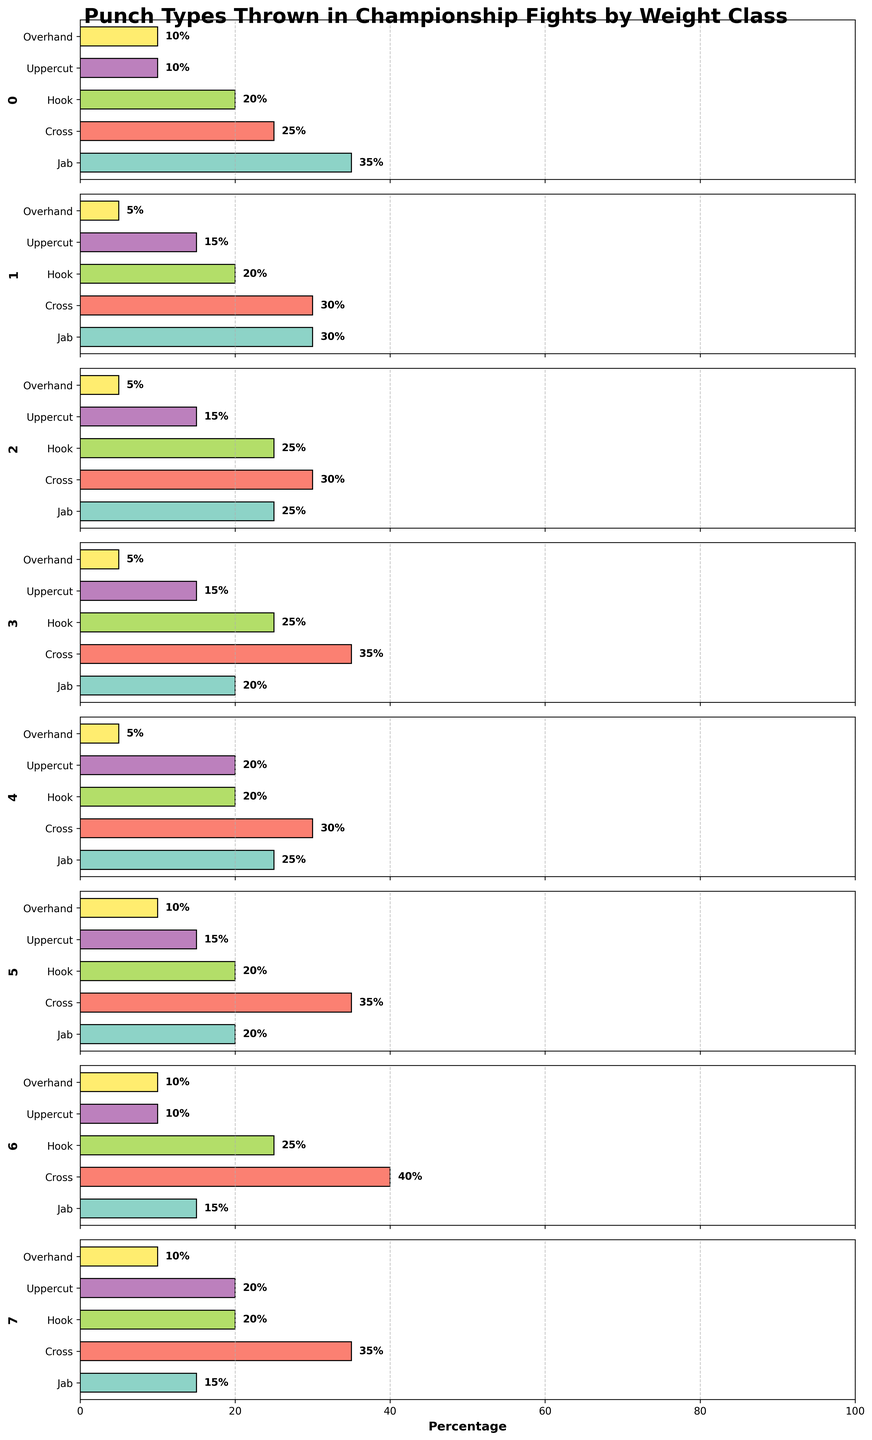What is the title of the figure? The title is usually found at the top of the figure, describing its content.
Answer: Punch Types Thrown in Championship Fights by Weight Class Which punch type has the highest percentage for Flyweight? To find this, look at the Flyweight subplot and identify the punch with the longest bar.
Answer: Jab What is the total percentage of punches thrown for Bantamweight? Add up the percentages of all punch types in the Bantamweight subplot: 30 + 30 + 20 + 15 + 5.
Answer: 100% Which weight class throws the highest percentage of Cross punches? Examine the bars for Cross punches in each subplot and find the weight class with the longest bar.
Answer: Light Heavyweight How many data points are represented in the figure? Each subplot represents one weight class, and each weight class has five punch types, totaling 8 subplots.
Answer: 8 What is the percentage difference between Uppercut and Hook punches for Featherweight? Find the percentages of both punches in the Featherweight subplot and subtract them: 25 - 15.
Answer: 10% Which weight class throws the least percentage of Jab punches? Look at Jab punches across all subplots and identify the weight class with the shortest bar.
Answer: Light Heavyweight and Heavyweight (both 15%) Compare the percentages of Overhand punches thrown by Lightweight and Heavyweight. Check the Overhand punch percentages in the Lightweight and Heavyweight subplots and compare them.
Answer: Both are 10% In which weight class is the percentage of Hooks and Crosses equal? Look for a subplot where the Heights of the bars for Hook and Cross are the same.
Answer: Featherweight What is the average percentage of Cross punches thrown across all weight classes? Add the percentages of Cross punches from all weight classes and divide by the number of classes: (25 + 30 + 30 + 35 + 30 + 35 + 40 + 35) / 8.
Answer: 32.5% 